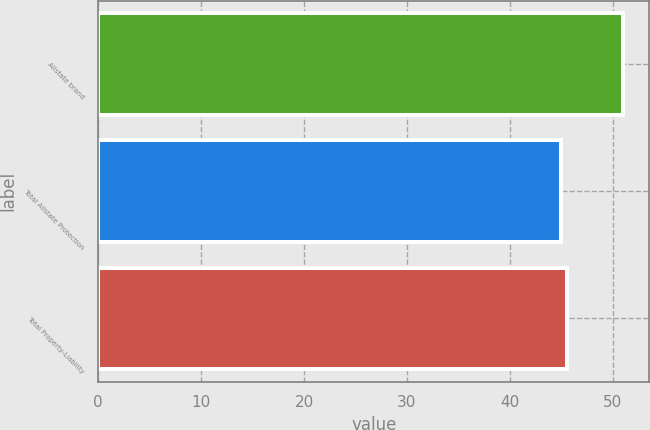Convert chart. <chart><loc_0><loc_0><loc_500><loc_500><bar_chart><fcel>Allstate brand<fcel>Total Allstate Protection<fcel>Total Property-Liability<nl><fcel>51<fcel>45<fcel>45.6<nl></chart> 